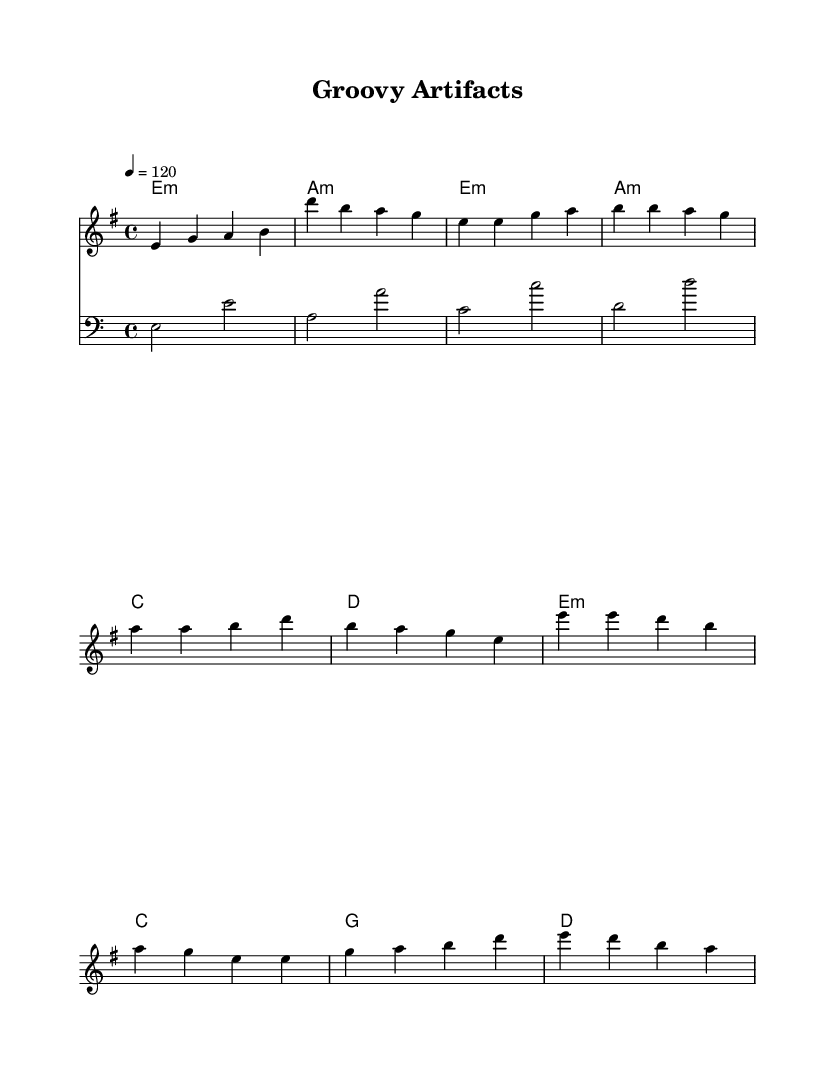What is the key signature of this music? The key signature is E minor, which includes one sharp (F#), indicating the tonal center is E minor.
Answer: E minor What is the time signature of the piece? The time signature displayed is 4/4, signifying four beats per measure, which is standard for disco music.
Answer: 4/4 What is the tempo marking for this piece? The tempo marking indicates that the piece should be played at a speed of 120 beats per minute, contributing to the upbeat nature typical of disco music.
Answer: 120 How many measures are in the intro section? The intro consists of two measures as indicated by the note sequence before the first verse starts.
Answer: 2 What is the first note of the melody? The first note of the melody is E, as it is the starting pitch in the sequence.
Answer: E Which chord is used in the chorus? The chorus includes several chords, but the first chord in this section is E minor, which sets the harmonic foundation.
Answer: E minor How many distinct sections are there in the music? The piece has three distinct sections: an intro, a verse, and a chorus, demonstrating a typical structure in disco tracks.
Answer: 3 